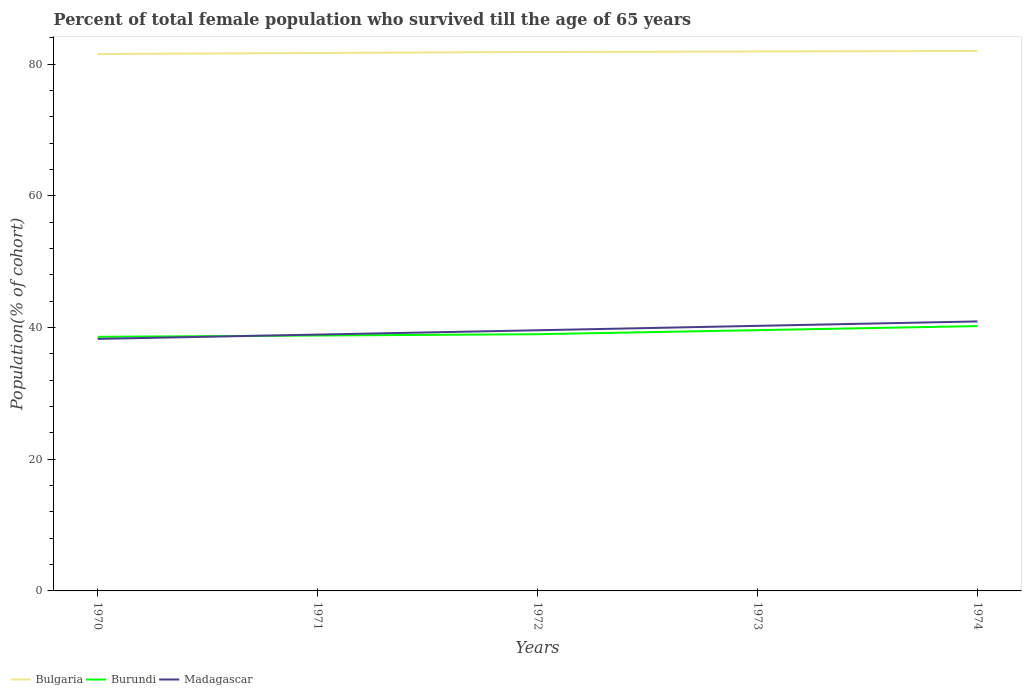How many different coloured lines are there?
Offer a very short reply. 3. Does the line corresponding to Madagascar intersect with the line corresponding to Bulgaria?
Offer a very short reply. No. Is the number of lines equal to the number of legend labels?
Provide a succinct answer. Yes. Across all years, what is the maximum percentage of total female population who survived till the age of 65 years in Bulgaria?
Provide a short and direct response. 81.53. In which year was the percentage of total female population who survived till the age of 65 years in Bulgaria maximum?
Offer a terse response. 1970. What is the total percentage of total female population who survived till the age of 65 years in Madagascar in the graph?
Your response must be concise. -2. What is the difference between the highest and the second highest percentage of total female population who survived till the age of 65 years in Burundi?
Provide a succinct answer. 1.63. How many lines are there?
Provide a short and direct response. 3. What is the difference between two consecutive major ticks on the Y-axis?
Provide a short and direct response. 20. Are the values on the major ticks of Y-axis written in scientific E-notation?
Provide a succinct answer. No. Does the graph contain any zero values?
Make the answer very short. No. Does the graph contain grids?
Give a very brief answer. No. How are the legend labels stacked?
Your answer should be very brief. Horizontal. What is the title of the graph?
Offer a very short reply. Percent of total female population who survived till the age of 65 years. Does "Kenya" appear as one of the legend labels in the graph?
Provide a short and direct response. No. What is the label or title of the Y-axis?
Offer a terse response. Population(% of cohort). What is the Population(% of cohort) of Bulgaria in 1970?
Your response must be concise. 81.53. What is the Population(% of cohort) in Burundi in 1970?
Your answer should be very brief. 38.59. What is the Population(% of cohort) of Madagascar in 1970?
Offer a terse response. 38.27. What is the Population(% of cohort) in Bulgaria in 1971?
Your answer should be very brief. 81.68. What is the Population(% of cohort) in Burundi in 1971?
Provide a short and direct response. 38.78. What is the Population(% of cohort) of Madagascar in 1971?
Provide a short and direct response. 38.92. What is the Population(% of cohort) in Bulgaria in 1972?
Provide a succinct answer. 81.84. What is the Population(% of cohort) in Burundi in 1972?
Your answer should be compact. 38.98. What is the Population(% of cohort) in Madagascar in 1972?
Your response must be concise. 39.58. What is the Population(% of cohort) of Bulgaria in 1973?
Your response must be concise. 81.91. What is the Population(% of cohort) in Burundi in 1973?
Keep it short and to the point. 39.6. What is the Population(% of cohort) of Madagascar in 1973?
Offer a very short reply. 40.25. What is the Population(% of cohort) of Bulgaria in 1974?
Provide a succinct answer. 81.99. What is the Population(% of cohort) in Burundi in 1974?
Make the answer very short. 40.21. What is the Population(% of cohort) of Madagascar in 1974?
Ensure brevity in your answer.  40.92. Across all years, what is the maximum Population(% of cohort) in Bulgaria?
Provide a succinct answer. 81.99. Across all years, what is the maximum Population(% of cohort) in Burundi?
Make the answer very short. 40.21. Across all years, what is the maximum Population(% of cohort) in Madagascar?
Give a very brief answer. 40.92. Across all years, what is the minimum Population(% of cohort) in Bulgaria?
Ensure brevity in your answer.  81.53. Across all years, what is the minimum Population(% of cohort) in Burundi?
Offer a very short reply. 38.59. Across all years, what is the minimum Population(% of cohort) of Madagascar?
Make the answer very short. 38.27. What is the total Population(% of cohort) of Bulgaria in the graph?
Make the answer very short. 408.95. What is the total Population(% of cohort) in Burundi in the graph?
Your answer should be very brief. 196.16. What is the total Population(% of cohort) in Madagascar in the graph?
Make the answer very short. 197.95. What is the difference between the Population(% of cohort) in Bulgaria in 1970 and that in 1971?
Offer a terse response. -0.15. What is the difference between the Population(% of cohort) in Burundi in 1970 and that in 1971?
Offer a terse response. -0.2. What is the difference between the Population(% of cohort) in Madagascar in 1970 and that in 1971?
Provide a succinct answer. -0.65. What is the difference between the Population(% of cohort) of Bulgaria in 1970 and that in 1972?
Offer a terse response. -0.31. What is the difference between the Population(% of cohort) of Burundi in 1970 and that in 1972?
Keep it short and to the point. -0.39. What is the difference between the Population(% of cohort) in Madagascar in 1970 and that in 1972?
Give a very brief answer. -1.31. What is the difference between the Population(% of cohort) of Bulgaria in 1970 and that in 1973?
Provide a short and direct response. -0.38. What is the difference between the Population(% of cohort) of Burundi in 1970 and that in 1973?
Your answer should be very brief. -1.01. What is the difference between the Population(% of cohort) of Madagascar in 1970 and that in 1973?
Provide a succinct answer. -1.98. What is the difference between the Population(% of cohort) in Bulgaria in 1970 and that in 1974?
Provide a succinct answer. -0.46. What is the difference between the Population(% of cohort) of Burundi in 1970 and that in 1974?
Keep it short and to the point. -1.63. What is the difference between the Population(% of cohort) in Madagascar in 1970 and that in 1974?
Your answer should be very brief. -2.65. What is the difference between the Population(% of cohort) in Bulgaria in 1971 and that in 1972?
Your answer should be compact. -0.15. What is the difference between the Population(% of cohort) in Burundi in 1971 and that in 1972?
Offer a very short reply. -0.2. What is the difference between the Population(% of cohort) in Madagascar in 1971 and that in 1972?
Provide a succinct answer. -0.65. What is the difference between the Population(% of cohort) in Bulgaria in 1971 and that in 1973?
Offer a terse response. -0.23. What is the difference between the Population(% of cohort) of Burundi in 1971 and that in 1973?
Ensure brevity in your answer.  -0.81. What is the difference between the Population(% of cohort) in Madagascar in 1971 and that in 1973?
Make the answer very short. -1.33. What is the difference between the Population(% of cohort) of Bulgaria in 1971 and that in 1974?
Ensure brevity in your answer.  -0.31. What is the difference between the Population(% of cohort) in Burundi in 1971 and that in 1974?
Keep it short and to the point. -1.43. What is the difference between the Population(% of cohort) in Madagascar in 1971 and that in 1974?
Your answer should be compact. -2. What is the difference between the Population(% of cohort) in Bulgaria in 1972 and that in 1973?
Your answer should be very brief. -0.08. What is the difference between the Population(% of cohort) of Burundi in 1972 and that in 1973?
Your response must be concise. -0.62. What is the difference between the Population(% of cohort) of Madagascar in 1972 and that in 1973?
Give a very brief answer. -0.67. What is the difference between the Population(% of cohort) in Bulgaria in 1972 and that in 1974?
Provide a succinct answer. -0.15. What is the difference between the Population(% of cohort) in Burundi in 1972 and that in 1974?
Your response must be concise. -1.23. What is the difference between the Population(% of cohort) of Madagascar in 1972 and that in 1974?
Provide a succinct answer. -1.34. What is the difference between the Population(% of cohort) of Bulgaria in 1973 and that in 1974?
Make the answer very short. -0.08. What is the difference between the Population(% of cohort) of Burundi in 1973 and that in 1974?
Make the answer very short. -0.62. What is the difference between the Population(% of cohort) in Madagascar in 1973 and that in 1974?
Your answer should be compact. -0.67. What is the difference between the Population(% of cohort) in Bulgaria in 1970 and the Population(% of cohort) in Burundi in 1971?
Offer a terse response. 42.75. What is the difference between the Population(% of cohort) in Bulgaria in 1970 and the Population(% of cohort) in Madagascar in 1971?
Keep it short and to the point. 42.6. What is the difference between the Population(% of cohort) of Burundi in 1970 and the Population(% of cohort) of Madagascar in 1971?
Offer a very short reply. -0.34. What is the difference between the Population(% of cohort) of Bulgaria in 1970 and the Population(% of cohort) of Burundi in 1972?
Keep it short and to the point. 42.55. What is the difference between the Population(% of cohort) of Bulgaria in 1970 and the Population(% of cohort) of Madagascar in 1972?
Offer a terse response. 41.95. What is the difference between the Population(% of cohort) in Burundi in 1970 and the Population(% of cohort) in Madagascar in 1972?
Offer a very short reply. -0.99. What is the difference between the Population(% of cohort) in Bulgaria in 1970 and the Population(% of cohort) in Burundi in 1973?
Your response must be concise. 41.93. What is the difference between the Population(% of cohort) of Bulgaria in 1970 and the Population(% of cohort) of Madagascar in 1973?
Give a very brief answer. 41.28. What is the difference between the Population(% of cohort) in Burundi in 1970 and the Population(% of cohort) in Madagascar in 1973?
Keep it short and to the point. -1.66. What is the difference between the Population(% of cohort) in Bulgaria in 1970 and the Population(% of cohort) in Burundi in 1974?
Provide a succinct answer. 41.32. What is the difference between the Population(% of cohort) of Bulgaria in 1970 and the Population(% of cohort) of Madagascar in 1974?
Your answer should be compact. 40.61. What is the difference between the Population(% of cohort) of Burundi in 1970 and the Population(% of cohort) of Madagascar in 1974?
Offer a terse response. -2.34. What is the difference between the Population(% of cohort) in Bulgaria in 1971 and the Population(% of cohort) in Burundi in 1972?
Keep it short and to the point. 42.7. What is the difference between the Population(% of cohort) in Bulgaria in 1971 and the Population(% of cohort) in Madagascar in 1972?
Ensure brevity in your answer.  42.1. What is the difference between the Population(% of cohort) in Burundi in 1971 and the Population(% of cohort) in Madagascar in 1972?
Provide a short and direct response. -0.8. What is the difference between the Population(% of cohort) of Bulgaria in 1971 and the Population(% of cohort) of Burundi in 1973?
Ensure brevity in your answer.  42.09. What is the difference between the Population(% of cohort) of Bulgaria in 1971 and the Population(% of cohort) of Madagascar in 1973?
Provide a succinct answer. 41.43. What is the difference between the Population(% of cohort) of Burundi in 1971 and the Population(% of cohort) of Madagascar in 1973?
Your answer should be compact. -1.47. What is the difference between the Population(% of cohort) in Bulgaria in 1971 and the Population(% of cohort) in Burundi in 1974?
Your answer should be very brief. 41.47. What is the difference between the Population(% of cohort) in Bulgaria in 1971 and the Population(% of cohort) in Madagascar in 1974?
Provide a succinct answer. 40.76. What is the difference between the Population(% of cohort) in Burundi in 1971 and the Population(% of cohort) in Madagascar in 1974?
Provide a short and direct response. -2.14. What is the difference between the Population(% of cohort) in Bulgaria in 1972 and the Population(% of cohort) in Burundi in 1973?
Provide a succinct answer. 42.24. What is the difference between the Population(% of cohort) of Bulgaria in 1972 and the Population(% of cohort) of Madagascar in 1973?
Offer a terse response. 41.59. What is the difference between the Population(% of cohort) of Burundi in 1972 and the Population(% of cohort) of Madagascar in 1973?
Ensure brevity in your answer.  -1.27. What is the difference between the Population(% of cohort) in Bulgaria in 1972 and the Population(% of cohort) in Burundi in 1974?
Keep it short and to the point. 41.62. What is the difference between the Population(% of cohort) of Bulgaria in 1972 and the Population(% of cohort) of Madagascar in 1974?
Give a very brief answer. 40.91. What is the difference between the Population(% of cohort) of Burundi in 1972 and the Population(% of cohort) of Madagascar in 1974?
Your answer should be very brief. -1.94. What is the difference between the Population(% of cohort) of Bulgaria in 1973 and the Population(% of cohort) of Burundi in 1974?
Keep it short and to the point. 41.7. What is the difference between the Population(% of cohort) in Bulgaria in 1973 and the Population(% of cohort) in Madagascar in 1974?
Provide a succinct answer. 40.99. What is the difference between the Population(% of cohort) of Burundi in 1973 and the Population(% of cohort) of Madagascar in 1974?
Make the answer very short. -1.33. What is the average Population(% of cohort) in Bulgaria per year?
Offer a terse response. 81.79. What is the average Population(% of cohort) in Burundi per year?
Keep it short and to the point. 39.23. What is the average Population(% of cohort) of Madagascar per year?
Give a very brief answer. 39.59. In the year 1970, what is the difference between the Population(% of cohort) of Bulgaria and Population(% of cohort) of Burundi?
Your answer should be very brief. 42.94. In the year 1970, what is the difference between the Population(% of cohort) in Bulgaria and Population(% of cohort) in Madagascar?
Your answer should be compact. 43.26. In the year 1970, what is the difference between the Population(% of cohort) of Burundi and Population(% of cohort) of Madagascar?
Your answer should be compact. 0.32. In the year 1971, what is the difference between the Population(% of cohort) in Bulgaria and Population(% of cohort) in Burundi?
Your response must be concise. 42.9. In the year 1971, what is the difference between the Population(% of cohort) of Bulgaria and Population(% of cohort) of Madagascar?
Your answer should be very brief. 42.76. In the year 1971, what is the difference between the Population(% of cohort) in Burundi and Population(% of cohort) in Madagascar?
Offer a terse response. -0.14. In the year 1972, what is the difference between the Population(% of cohort) of Bulgaria and Population(% of cohort) of Burundi?
Make the answer very short. 42.86. In the year 1972, what is the difference between the Population(% of cohort) of Bulgaria and Population(% of cohort) of Madagascar?
Give a very brief answer. 42.26. In the year 1972, what is the difference between the Population(% of cohort) in Burundi and Population(% of cohort) in Madagascar?
Offer a very short reply. -0.6. In the year 1973, what is the difference between the Population(% of cohort) in Bulgaria and Population(% of cohort) in Burundi?
Your answer should be very brief. 42.32. In the year 1973, what is the difference between the Population(% of cohort) in Bulgaria and Population(% of cohort) in Madagascar?
Offer a terse response. 41.66. In the year 1973, what is the difference between the Population(% of cohort) of Burundi and Population(% of cohort) of Madagascar?
Offer a very short reply. -0.65. In the year 1974, what is the difference between the Population(% of cohort) in Bulgaria and Population(% of cohort) in Burundi?
Your answer should be compact. 41.78. In the year 1974, what is the difference between the Population(% of cohort) in Bulgaria and Population(% of cohort) in Madagascar?
Provide a short and direct response. 41.07. In the year 1974, what is the difference between the Population(% of cohort) in Burundi and Population(% of cohort) in Madagascar?
Offer a very short reply. -0.71. What is the ratio of the Population(% of cohort) in Madagascar in 1970 to that in 1971?
Provide a short and direct response. 0.98. What is the ratio of the Population(% of cohort) in Burundi in 1970 to that in 1972?
Your answer should be compact. 0.99. What is the ratio of the Population(% of cohort) in Madagascar in 1970 to that in 1972?
Ensure brevity in your answer.  0.97. What is the ratio of the Population(% of cohort) in Burundi in 1970 to that in 1973?
Your response must be concise. 0.97. What is the ratio of the Population(% of cohort) in Madagascar in 1970 to that in 1973?
Your answer should be very brief. 0.95. What is the ratio of the Population(% of cohort) of Bulgaria in 1970 to that in 1974?
Provide a succinct answer. 0.99. What is the ratio of the Population(% of cohort) in Burundi in 1970 to that in 1974?
Provide a short and direct response. 0.96. What is the ratio of the Population(% of cohort) of Madagascar in 1970 to that in 1974?
Make the answer very short. 0.94. What is the ratio of the Population(% of cohort) of Bulgaria in 1971 to that in 1972?
Your answer should be compact. 1. What is the ratio of the Population(% of cohort) in Burundi in 1971 to that in 1972?
Offer a very short reply. 0.99. What is the ratio of the Population(% of cohort) of Madagascar in 1971 to that in 1972?
Keep it short and to the point. 0.98. What is the ratio of the Population(% of cohort) of Bulgaria in 1971 to that in 1973?
Your answer should be very brief. 1. What is the ratio of the Population(% of cohort) in Burundi in 1971 to that in 1973?
Ensure brevity in your answer.  0.98. What is the ratio of the Population(% of cohort) of Madagascar in 1971 to that in 1973?
Make the answer very short. 0.97. What is the ratio of the Population(% of cohort) of Burundi in 1971 to that in 1974?
Your answer should be compact. 0.96. What is the ratio of the Population(% of cohort) of Madagascar in 1971 to that in 1974?
Give a very brief answer. 0.95. What is the ratio of the Population(% of cohort) of Bulgaria in 1972 to that in 1973?
Your response must be concise. 1. What is the ratio of the Population(% of cohort) in Burundi in 1972 to that in 1973?
Provide a succinct answer. 0.98. What is the ratio of the Population(% of cohort) in Madagascar in 1972 to that in 1973?
Provide a short and direct response. 0.98. What is the ratio of the Population(% of cohort) of Burundi in 1972 to that in 1974?
Keep it short and to the point. 0.97. What is the ratio of the Population(% of cohort) in Madagascar in 1972 to that in 1974?
Provide a succinct answer. 0.97. What is the ratio of the Population(% of cohort) of Bulgaria in 1973 to that in 1974?
Give a very brief answer. 1. What is the ratio of the Population(% of cohort) of Burundi in 1973 to that in 1974?
Provide a short and direct response. 0.98. What is the ratio of the Population(% of cohort) of Madagascar in 1973 to that in 1974?
Your answer should be very brief. 0.98. What is the difference between the highest and the second highest Population(% of cohort) of Bulgaria?
Ensure brevity in your answer.  0.08. What is the difference between the highest and the second highest Population(% of cohort) of Burundi?
Provide a short and direct response. 0.62. What is the difference between the highest and the second highest Population(% of cohort) in Madagascar?
Your response must be concise. 0.67. What is the difference between the highest and the lowest Population(% of cohort) in Bulgaria?
Offer a very short reply. 0.46. What is the difference between the highest and the lowest Population(% of cohort) in Burundi?
Your response must be concise. 1.63. What is the difference between the highest and the lowest Population(% of cohort) of Madagascar?
Offer a terse response. 2.65. 